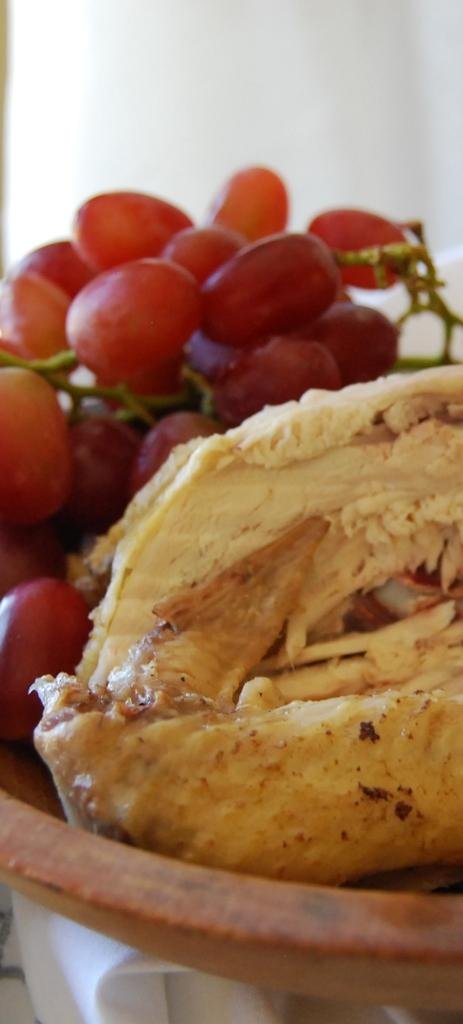What is in the bowl that is visible in the image? There are food items in a bowl in the image. Where is the bowl located in the image? The bowl is in the middle of the image. What can be seen in the background of the image? There is a wall in the background of the image. What type of crime is being committed in the image? There is no crime being committed in the image; it features a bowl of food items in the middle of the image with a wall in the background. How many hands are visible in the image? There are no hands visible in the image. 